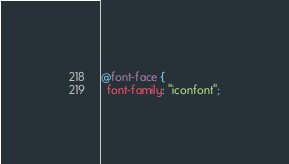Convert code to text. <code><loc_0><loc_0><loc_500><loc_500><_CSS_>@font-face {
  font-family: "iconfont";</code> 